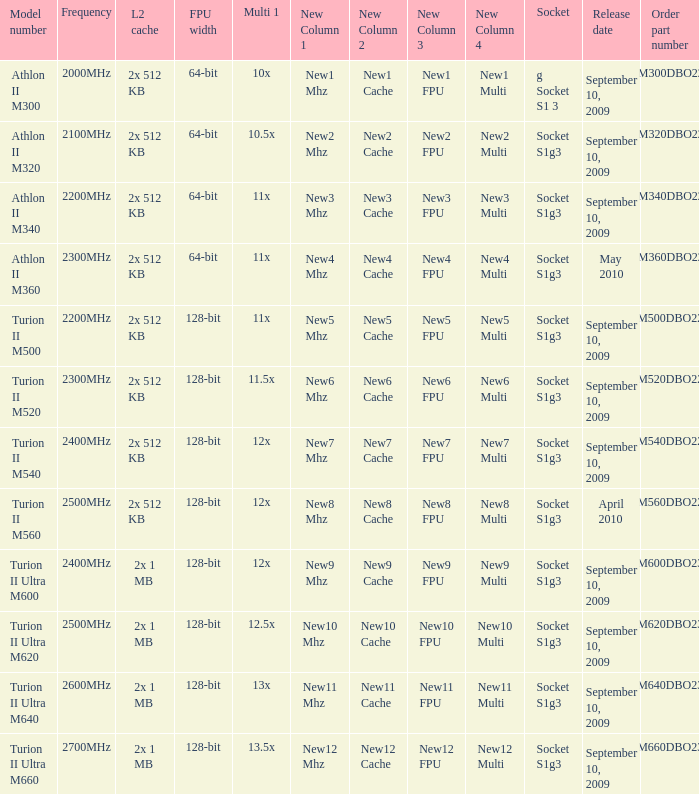What is the socket with an order part number of amm300dbo22gq and a September 10, 2009 release date? G socket s1 3. 